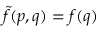Convert formula to latex. <formula><loc_0><loc_0><loc_500><loc_500>{ \tilde { f } } ( p , q ) = f ( q )</formula> 